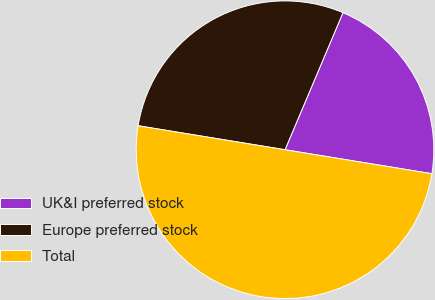Convert chart to OTSL. <chart><loc_0><loc_0><loc_500><loc_500><pie_chart><fcel>UK&I preferred stock<fcel>Europe preferred stock<fcel>Total<nl><fcel>21.21%<fcel>28.79%<fcel>50.0%<nl></chart> 